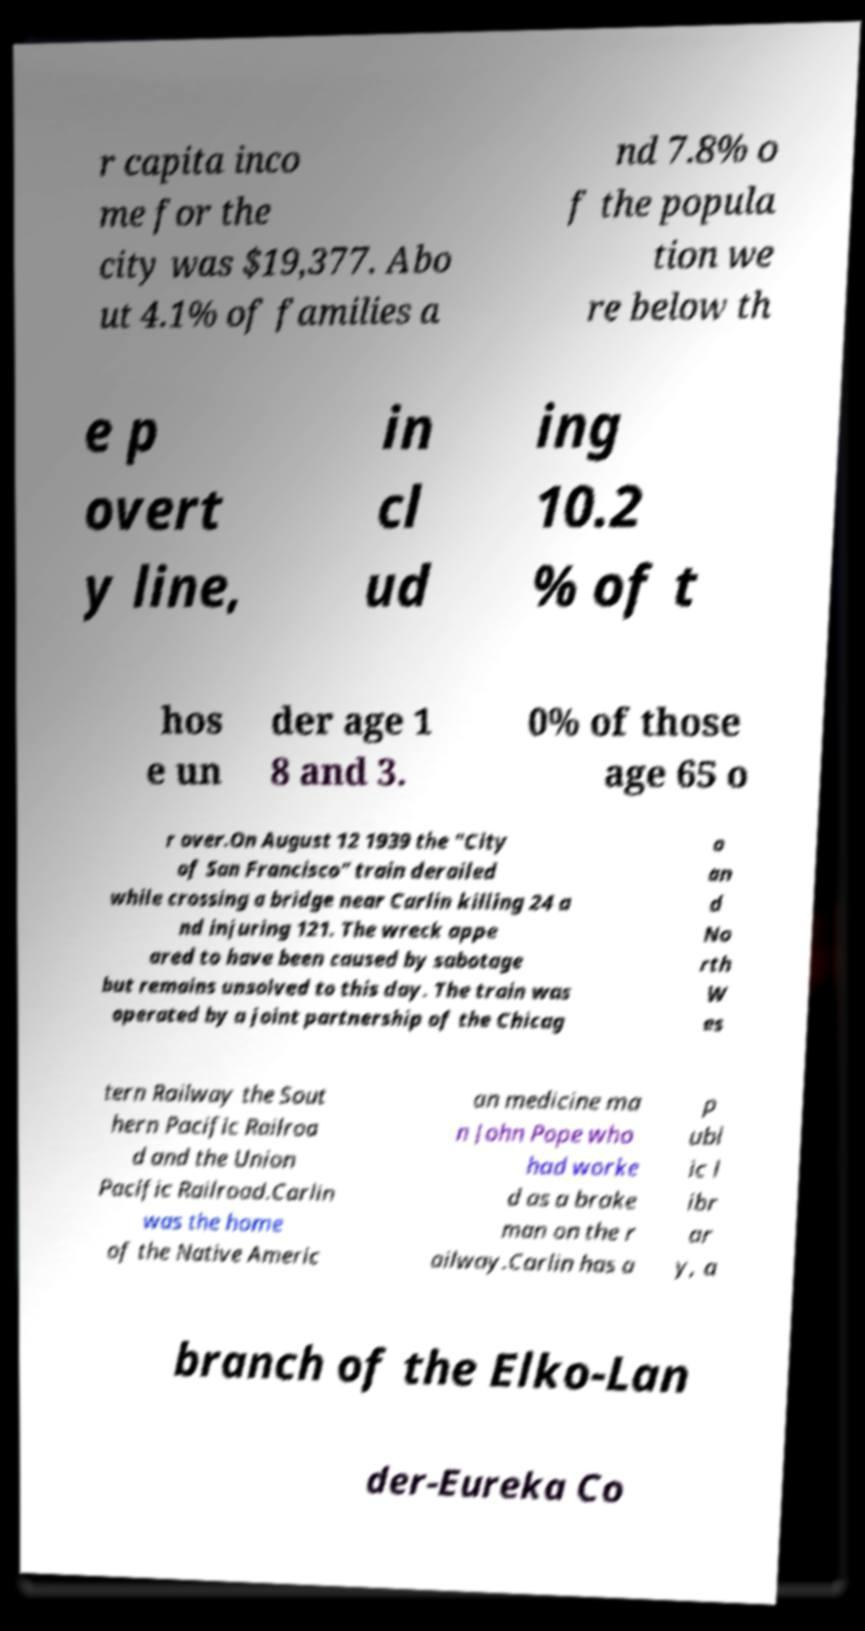Could you assist in decoding the text presented in this image and type it out clearly? r capita inco me for the city was $19,377. Abo ut 4.1% of families a nd 7.8% o f the popula tion we re below th e p overt y line, in cl ud ing 10.2 % of t hos e un der age 1 8 and 3. 0% of those age 65 o r over.On August 12 1939 the "City of San Francisco" train derailed while crossing a bridge near Carlin killing 24 a nd injuring 121. The wreck appe ared to have been caused by sabotage but remains unsolved to this day. The train was operated by a joint partnership of the Chicag o an d No rth W es tern Railway the Sout hern Pacific Railroa d and the Union Pacific Railroad.Carlin was the home of the Native Americ an medicine ma n John Pope who had worke d as a brake man on the r ailway.Carlin has a p ubl ic l ibr ar y, a branch of the Elko-Lan der-Eureka Co 